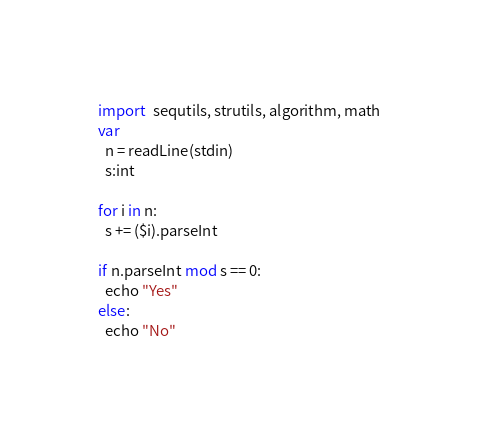Convert code to text. <code><loc_0><loc_0><loc_500><loc_500><_Nim_>import  sequtils, strutils, algorithm, math
var
  n = readLine(stdin)
  s:int

for i in n:
  s += ($i).parseInt

if n.parseInt mod s == 0:
  echo "Yes"
else:
  echo "No"</code> 